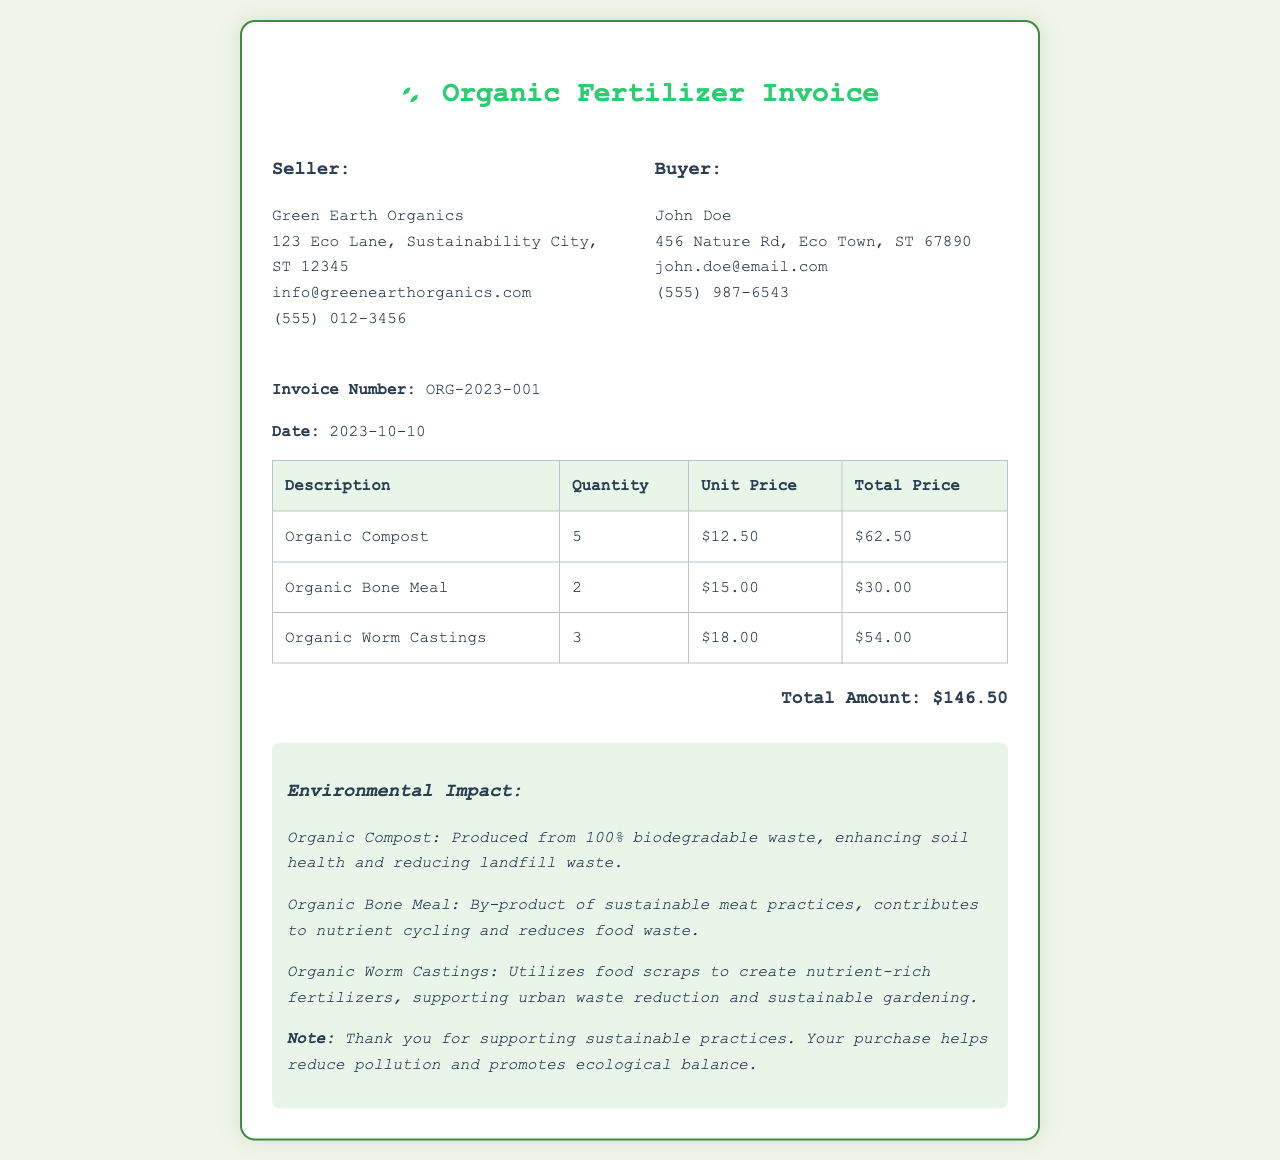What is the invoice number? The invoice number is provided in the invoice details as a unique identifier, which is ORG-2023-001.
Answer: ORG-2023-001 What is the total amount? The total amount is calculated based on the sum of all item prices, which is listed as $146.50.
Answer: $146.50 Who is the seller? The seller's details are listed at the top of the invoice, naming Green Earth Organics.
Answer: Green Earth Organics How many units of Organic Worm Castings were purchased? The quantity of Organic Worm Castings ordered is specified in the table, which shows 3 units.
Answer: 3 What is the environmental impact of Organic Compost? The impact details state that Organic Compost is produced from 100% biodegradable waste, enhancing soil health and reducing landfill waste.
Answer: Produced from 100% biodegradable waste What is the date of the invoice? The date of the invoice is clearly stated in the invoice details, which is 2023-10-10.
Answer: 2023-10-10 What is the buyer's email address? The buyer's email address is listed under the buyer section of the invoice, which is john.doe@email.com.
Answer: john.doe@email.com What does the note at the bottom emphasize? The note highlights appreciation for supporting sustainable practices and mentions that the purchase helps reduce pollution.
Answer: Reduces pollution and promotes ecological balance 